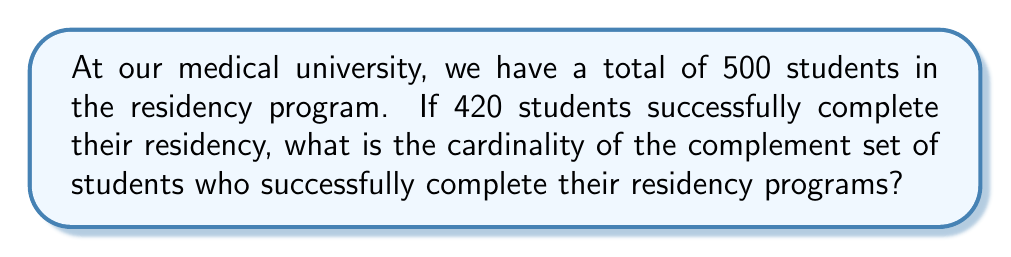What is the answer to this math problem? Let's approach this step-by-step using set theory:

1) Let $U$ be the universal set of all students in the residency program.
   $|U| = 500$

2) Let $A$ be the set of students who successfully complete their residency.
   $|A| = 420$

3) We need to find the complement of $A$, which we'll denote as $A^c$.

4) In set theory, the complement of a set $A$ is defined as all elements in the universal set $U$ that are not in $A$.

5) The cardinality of the complement can be calculated using the formula:
   $|A^c| = |U| - |A|$

6) Substituting our values:
   $|A^c| = 500 - 420 = 80$

Therefore, the cardinality of the complement set, which represents the number of students who do not successfully complete their residency programs, is 80.
Answer: 80 